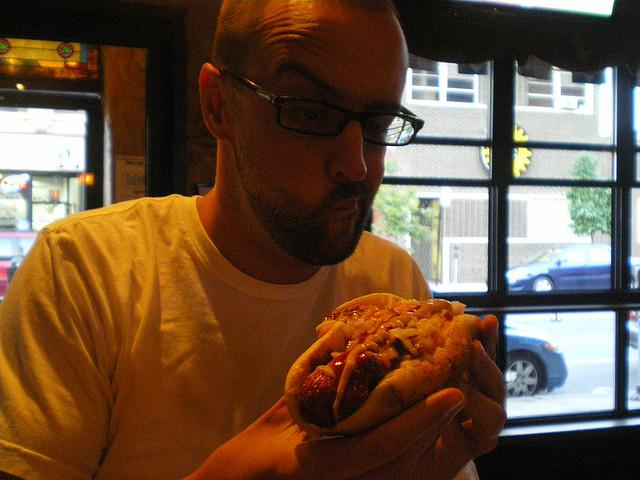Why does he have the huge sandwich? Please explain your reasoning. is hungry. The man is looking at it with an interested expression, and food is usually consumed for a specific reason. 